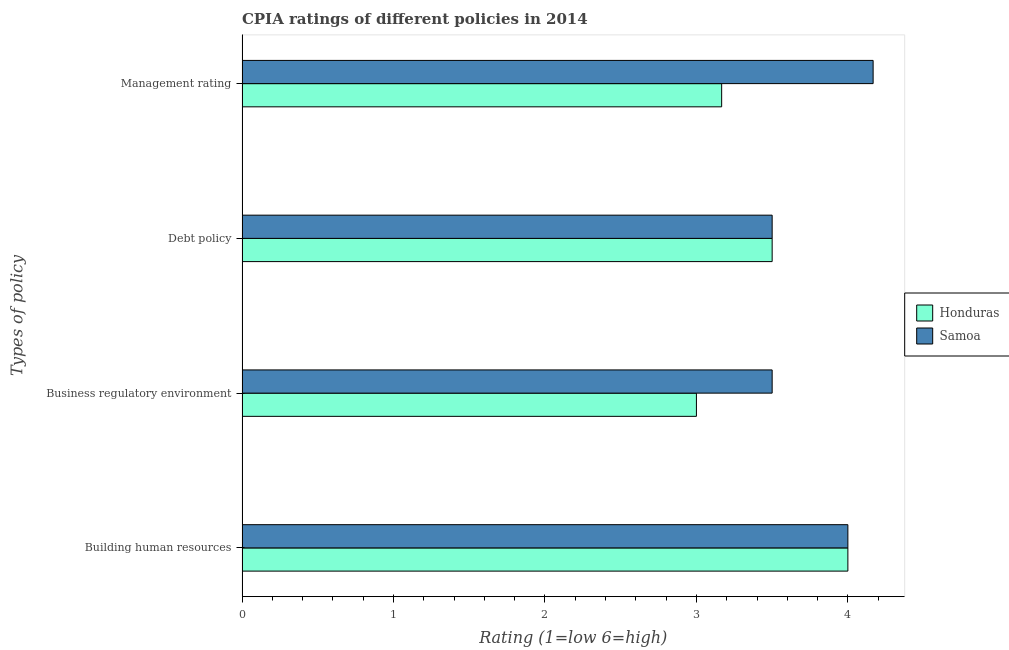How many different coloured bars are there?
Ensure brevity in your answer.  2. How many groups of bars are there?
Your response must be concise. 4. Are the number of bars per tick equal to the number of legend labels?
Provide a short and direct response. Yes. How many bars are there on the 2nd tick from the bottom?
Ensure brevity in your answer.  2. What is the label of the 3rd group of bars from the top?
Your answer should be very brief. Business regulatory environment. What is the cpia rating of business regulatory environment in Samoa?
Offer a terse response. 3.5. Across all countries, what is the maximum cpia rating of management?
Offer a terse response. 4.17. In which country was the cpia rating of building human resources maximum?
Keep it short and to the point. Honduras. In which country was the cpia rating of business regulatory environment minimum?
Your answer should be compact. Honduras. What is the total cpia rating of debt policy in the graph?
Provide a succinct answer. 7. What is the difference between the cpia rating of business regulatory environment in Samoa and that in Honduras?
Ensure brevity in your answer.  0.5. What is the difference between the cpia rating of building human resources in Samoa and the cpia rating of management in Honduras?
Make the answer very short. 0.83. What is the difference between the cpia rating of management and cpia rating of business regulatory environment in Honduras?
Your answer should be very brief. 0.17. In how many countries, is the cpia rating of building human resources greater than 1.4 ?
Your answer should be very brief. 2. Is the cpia rating of debt policy in Samoa less than that in Honduras?
Keep it short and to the point. No. What is the difference between the highest and the lowest cpia rating of management?
Ensure brevity in your answer.  1. In how many countries, is the cpia rating of business regulatory environment greater than the average cpia rating of business regulatory environment taken over all countries?
Offer a very short reply. 1. Is the sum of the cpia rating of business regulatory environment in Honduras and Samoa greater than the maximum cpia rating of management across all countries?
Your answer should be compact. Yes. Is it the case that in every country, the sum of the cpia rating of debt policy and cpia rating of business regulatory environment is greater than the sum of cpia rating of management and cpia rating of building human resources?
Your response must be concise. No. What does the 2nd bar from the top in Management rating represents?
Provide a succinct answer. Honduras. What does the 1st bar from the bottom in Business regulatory environment represents?
Your response must be concise. Honduras. Is it the case that in every country, the sum of the cpia rating of building human resources and cpia rating of business regulatory environment is greater than the cpia rating of debt policy?
Offer a very short reply. Yes. How many bars are there?
Give a very brief answer. 8. Are all the bars in the graph horizontal?
Give a very brief answer. Yes. What is the difference between two consecutive major ticks on the X-axis?
Provide a succinct answer. 1. Are the values on the major ticks of X-axis written in scientific E-notation?
Offer a terse response. No. Does the graph contain grids?
Give a very brief answer. No. How many legend labels are there?
Offer a very short reply. 2. How are the legend labels stacked?
Make the answer very short. Vertical. What is the title of the graph?
Give a very brief answer. CPIA ratings of different policies in 2014. Does "Guatemala" appear as one of the legend labels in the graph?
Provide a succinct answer. No. What is the label or title of the X-axis?
Your answer should be compact. Rating (1=low 6=high). What is the label or title of the Y-axis?
Provide a short and direct response. Types of policy. What is the Rating (1=low 6=high) of Honduras in Building human resources?
Make the answer very short. 4. What is the Rating (1=low 6=high) in Samoa in Debt policy?
Offer a terse response. 3.5. What is the Rating (1=low 6=high) of Honduras in Management rating?
Your answer should be compact. 3.17. What is the Rating (1=low 6=high) of Samoa in Management rating?
Your response must be concise. 4.17. Across all Types of policy, what is the maximum Rating (1=low 6=high) of Honduras?
Offer a terse response. 4. Across all Types of policy, what is the maximum Rating (1=low 6=high) in Samoa?
Your answer should be compact. 4.17. Across all Types of policy, what is the minimum Rating (1=low 6=high) of Honduras?
Your answer should be compact. 3. Across all Types of policy, what is the minimum Rating (1=low 6=high) in Samoa?
Offer a terse response. 3.5. What is the total Rating (1=low 6=high) of Honduras in the graph?
Your answer should be compact. 13.67. What is the total Rating (1=low 6=high) in Samoa in the graph?
Provide a short and direct response. 15.17. What is the difference between the Rating (1=low 6=high) in Honduras in Building human resources and that in Debt policy?
Provide a short and direct response. 0.5. What is the difference between the Rating (1=low 6=high) in Honduras in Building human resources and that in Management rating?
Your answer should be compact. 0.83. What is the difference between the Rating (1=low 6=high) in Samoa in Building human resources and that in Management rating?
Make the answer very short. -0.17. What is the difference between the Rating (1=low 6=high) of Honduras in Debt policy and that in Management rating?
Offer a very short reply. 0.33. What is the difference between the Rating (1=low 6=high) in Samoa in Debt policy and that in Management rating?
Keep it short and to the point. -0.67. What is the difference between the Rating (1=low 6=high) of Honduras in Business regulatory environment and the Rating (1=low 6=high) of Samoa in Management rating?
Provide a short and direct response. -1.17. What is the difference between the Rating (1=low 6=high) in Honduras in Debt policy and the Rating (1=low 6=high) in Samoa in Management rating?
Give a very brief answer. -0.67. What is the average Rating (1=low 6=high) in Honduras per Types of policy?
Give a very brief answer. 3.42. What is the average Rating (1=low 6=high) of Samoa per Types of policy?
Provide a short and direct response. 3.79. What is the difference between the Rating (1=low 6=high) in Honduras and Rating (1=low 6=high) in Samoa in Building human resources?
Offer a terse response. 0. What is the difference between the Rating (1=low 6=high) of Honduras and Rating (1=low 6=high) of Samoa in Debt policy?
Offer a terse response. 0. What is the ratio of the Rating (1=low 6=high) in Honduras in Building human resources to that in Debt policy?
Ensure brevity in your answer.  1.14. What is the ratio of the Rating (1=low 6=high) in Honduras in Building human resources to that in Management rating?
Give a very brief answer. 1.26. What is the ratio of the Rating (1=low 6=high) of Honduras in Business regulatory environment to that in Management rating?
Make the answer very short. 0.95. What is the ratio of the Rating (1=low 6=high) of Samoa in Business regulatory environment to that in Management rating?
Provide a short and direct response. 0.84. What is the ratio of the Rating (1=low 6=high) of Honduras in Debt policy to that in Management rating?
Your answer should be very brief. 1.11. What is the ratio of the Rating (1=low 6=high) of Samoa in Debt policy to that in Management rating?
Give a very brief answer. 0.84. What is the difference between the highest and the lowest Rating (1=low 6=high) of Honduras?
Give a very brief answer. 1. 